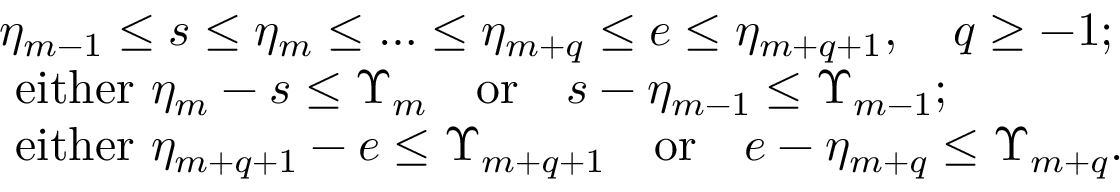Convert formula to latex. <formula><loc_0><loc_0><loc_500><loc_500>\begin{array} { r l } & { \eta _ { m - 1 } \leq s \leq \eta _ { m } \leq \dots \leq \eta _ { m + q } \leq e \leq \eta _ { m + q + 1 } , \quad q \geq - 1 ; } \\ & { e i t h e r \eta _ { m } - s \leq \Upsilon _ { m } \quad o r \quad s - \eta _ { m - 1 } \leq \Upsilon _ { m - 1 } ; } \\ & { e i t h e r \eta _ { m + q + 1 } - e \leq \Upsilon _ { m + q + 1 } \quad o r \quad e - \eta _ { m + q } \leq \Upsilon _ { m + q } . } \end{array}</formula> 